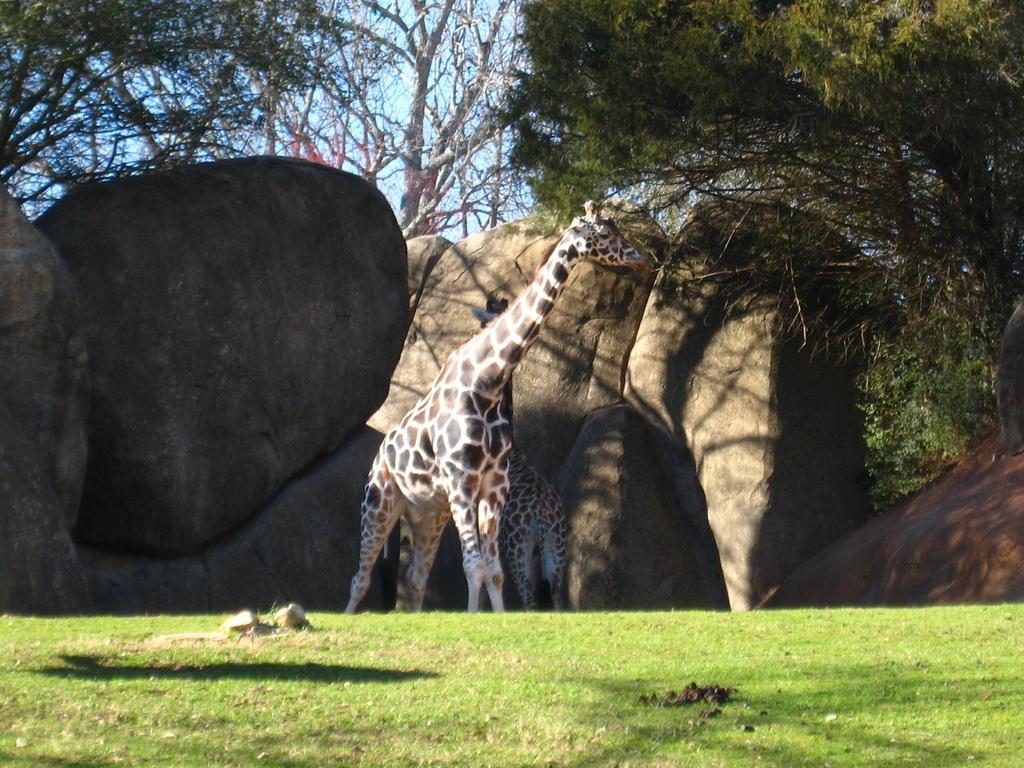Can you describe this image briefly? In this image I can see few giraffe. They are in brown,cream,black color. I can see few rocks,trees. The sky is in blue color. 